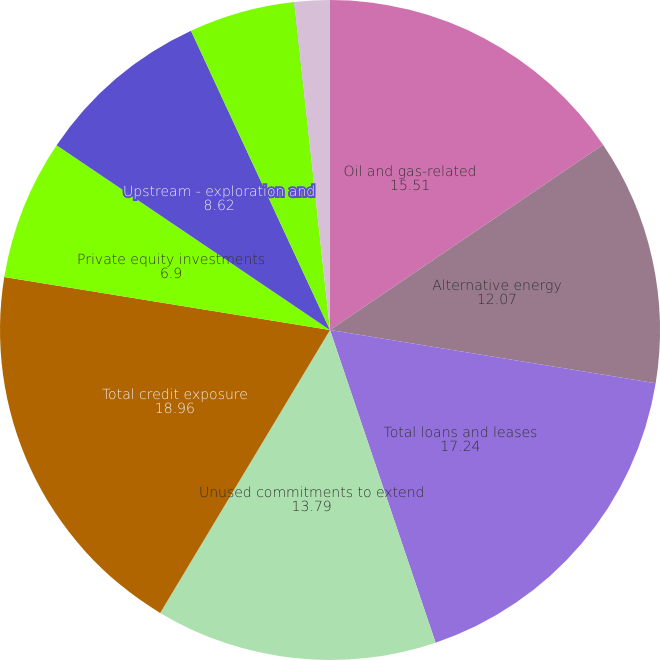<chart> <loc_0><loc_0><loc_500><loc_500><pie_chart><fcel>Oil and gas-related<fcel>Alternative energy<fcel>Total loans and leases<fcel>Unused commitments to extend<fcel>Total credit exposure<fcel>Private equity investments<fcel>Upstream - exploration and<fcel>Midstream - marketing and<fcel>Downstream - refining<fcel>Other non-services<nl><fcel>15.51%<fcel>12.07%<fcel>17.24%<fcel>13.79%<fcel>18.96%<fcel>6.9%<fcel>8.62%<fcel>5.18%<fcel>0.01%<fcel>1.73%<nl></chart> 